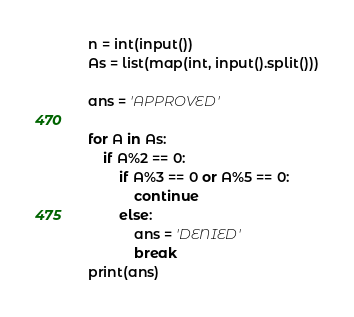Convert code to text. <code><loc_0><loc_0><loc_500><loc_500><_Python_>n = int(input())
As = list(map(int, input().split()))

ans = 'APPROVED'

for A in As:
    if A%2 == 0:
        if A%3 == 0 or A%5 == 0:
            continue
        else:
            ans = 'DENIED'
            break
print(ans)</code> 